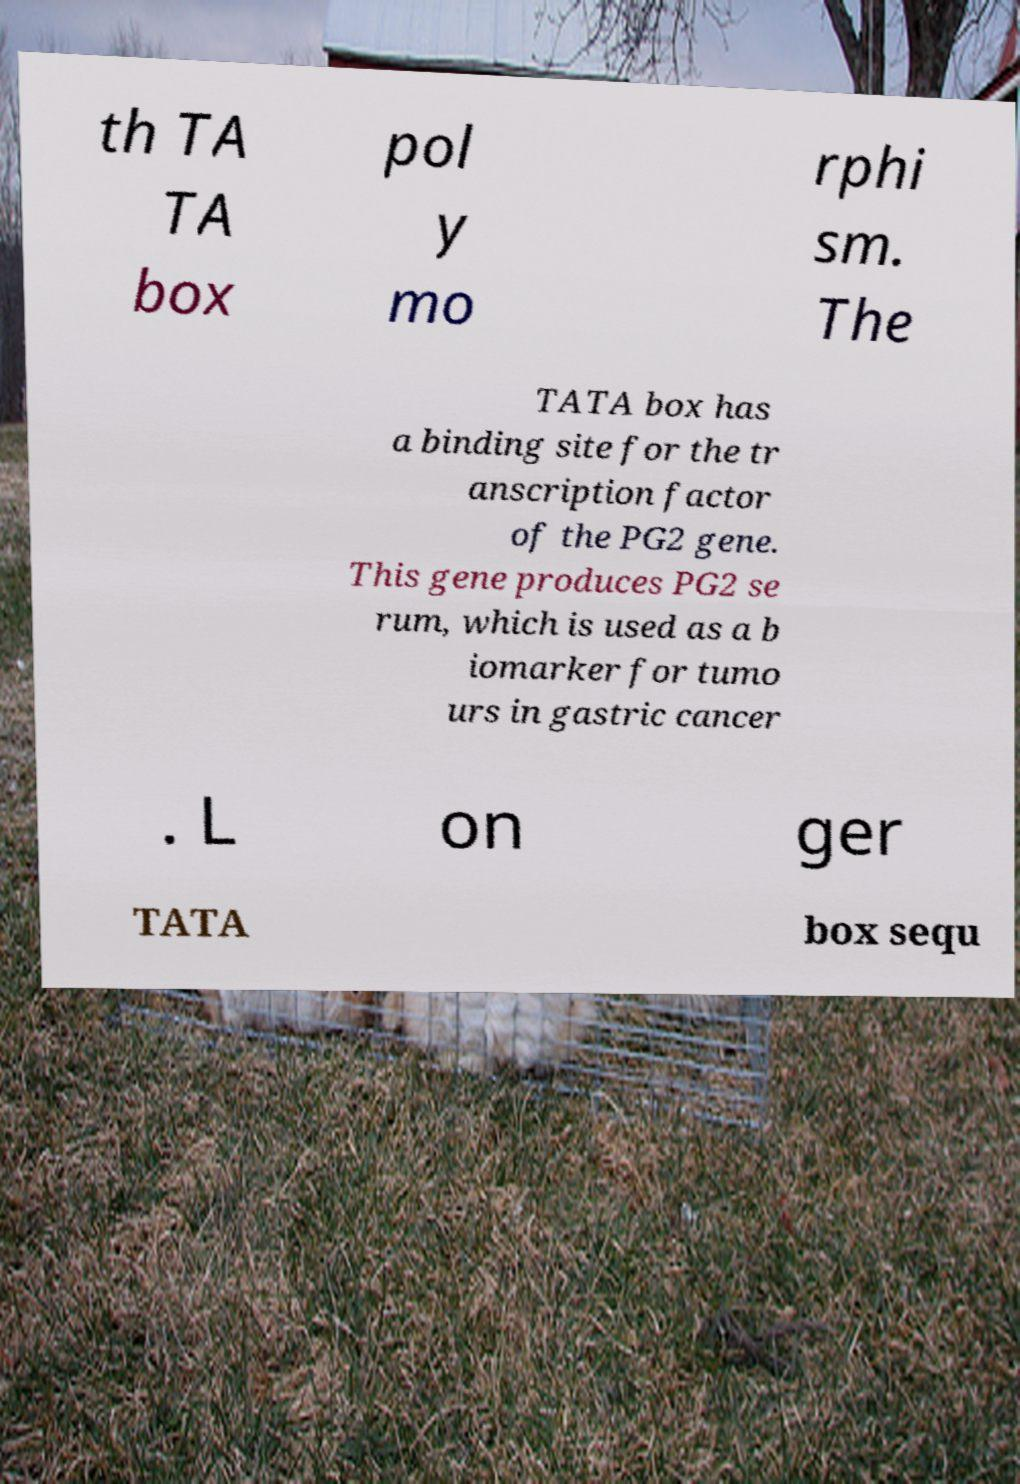For documentation purposes, I need the text within this image transcribed. Could you provide that? th TA TA box pol y mo rphi sm. The TATA box has a binding site for the tr anscription factor of the PG2 gene. This gene produces PG2 se rum, which is used as a b iomarker for tumo urs in gastric cancer . L on ger TATA box sequ 